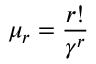<formula> <loc_0><loc_0><loc_500><loc_500>\mu _ { r } = \frac { r ! } { \gamma ^ { r } }</formula> 